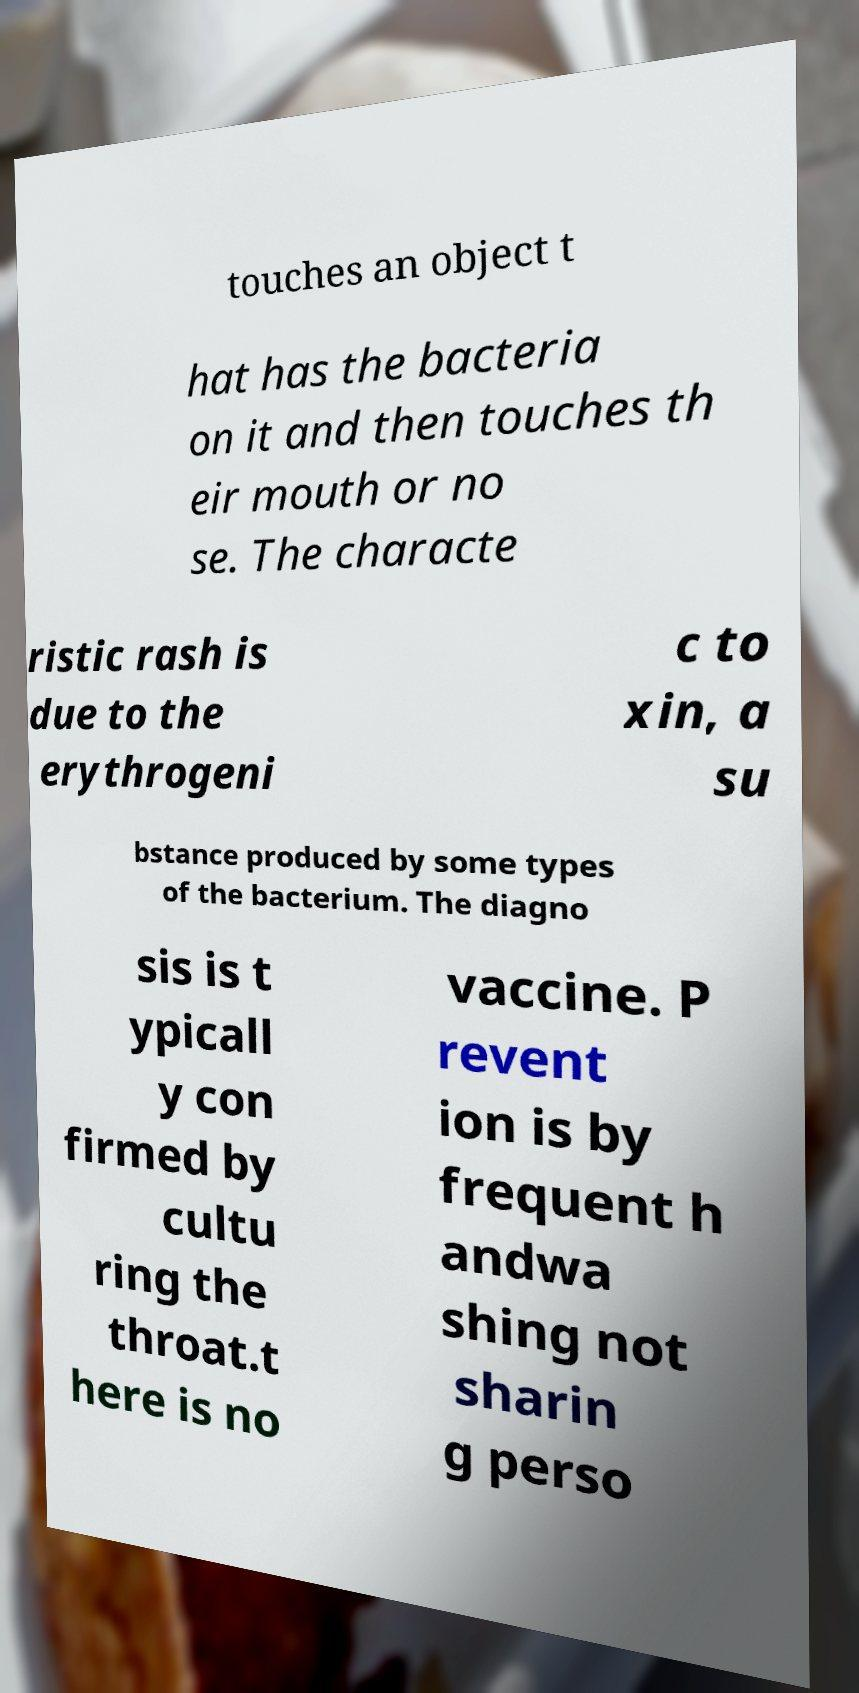Could you assist in decoding the text presented in this image and type it out clearly? touches an object t hat has the bacteria on it and then touches th eir mouth or no se. The characte ristic rash is due to the erythrogeni c to xin, a su bstance produced by some types of the bacterium. The diagno sis is t ypicall y con firmed by cultu ring the throat.t here is no vaccine. P revent ion is by frequent h andwa shing not sharin g perso 